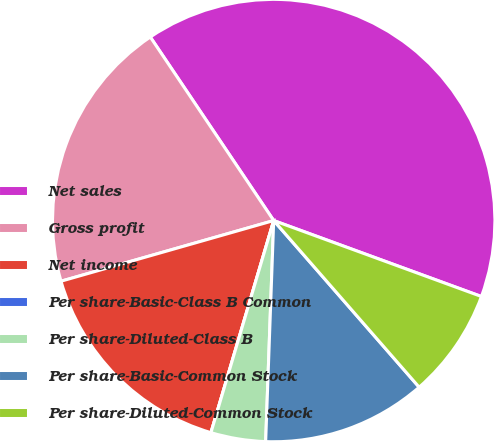Convert chart. <chart><loc_0><loc_0><loc_500><loc_500><pie_chart><fcel>Net sales<fcel>Gross profit<fcel>Net income<fcel>Per share-Basic-Class B Common<fcel>Per share-Diluted-Class B<fcel>Per share-Basic-Common Stock<fcel>Per share-Diluted-Common Stock<nl><fcel>40.0%<fcel>20.0%<fcel>16.0%<fcel>0.0%<fcel>4.0%<fcel>12.0%<fcel>8.0%<nl></chart> 